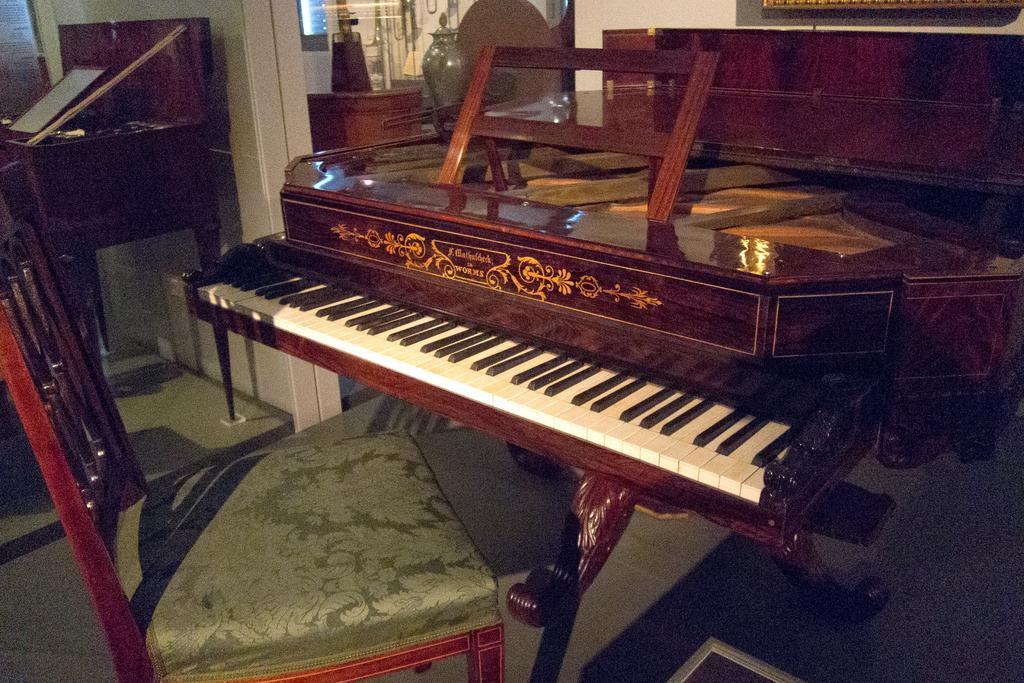In one or two sentences, can you explain what this image depicts? In this picture there is a piano which is placed at the right side of the image and there is a chair in front of the piano. 